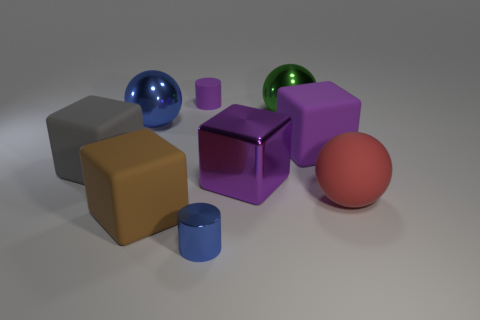There is a big shiny thing that is the same color as the tiny matte thing; what shape is it?
Ensure brevity in your answer.  Cube. Do the purple block behind the large gray matte cube and the blue shiny object that is behind the large purple metal object have the same size?
Provide a short and direct response. Yes. How many cylinders are big red objects or cyan rubber things?
Ensure brevity in your answer.  0. Are the small object that is behind the large red rubber ball and the big blue sphere made of the same material?
Keep it short and to the point. No. How many other objects are the same size as the blue cylinder?
Provide a succinct answer. 1. How many large objects are either blue metal blocks or metal cylinders?
Give a very brief answer. 0. Is the color of the large metallic block the same as the tiny rubber cylinder?
Ensure brevity in your answer.  Yes. Are there more purple cubes that are to the right of the purple metal object than large blue things that are on the right side of the tiny blue shiny object?
Provide a short and direct response. Yes. There is a cylinder that is behind the large blue metal ball; is its color the same as the big metal block?
Your answer should be very brief. Yes. Is there any other thing of the same color as the tiny metallic cylinder?
Offer a very short reply. Yes. 